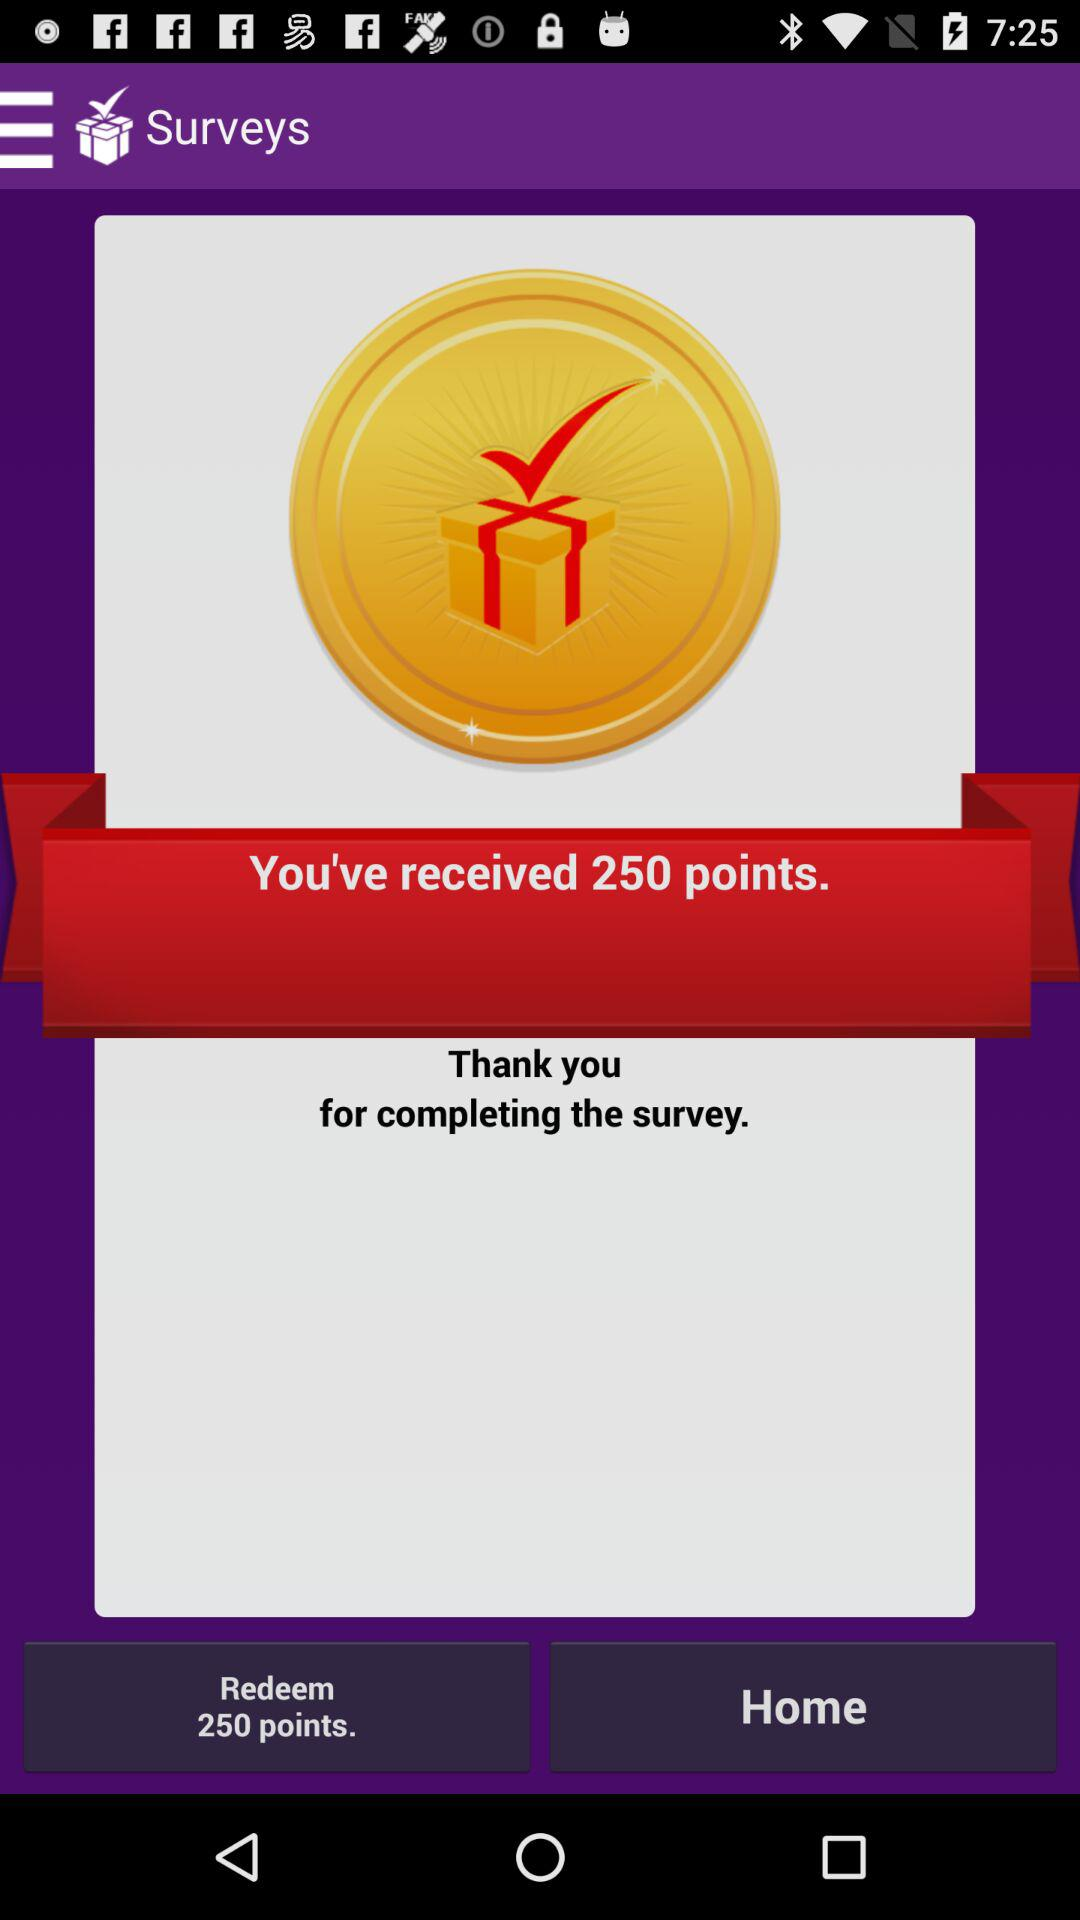How many points have you received? The received points are 250. 